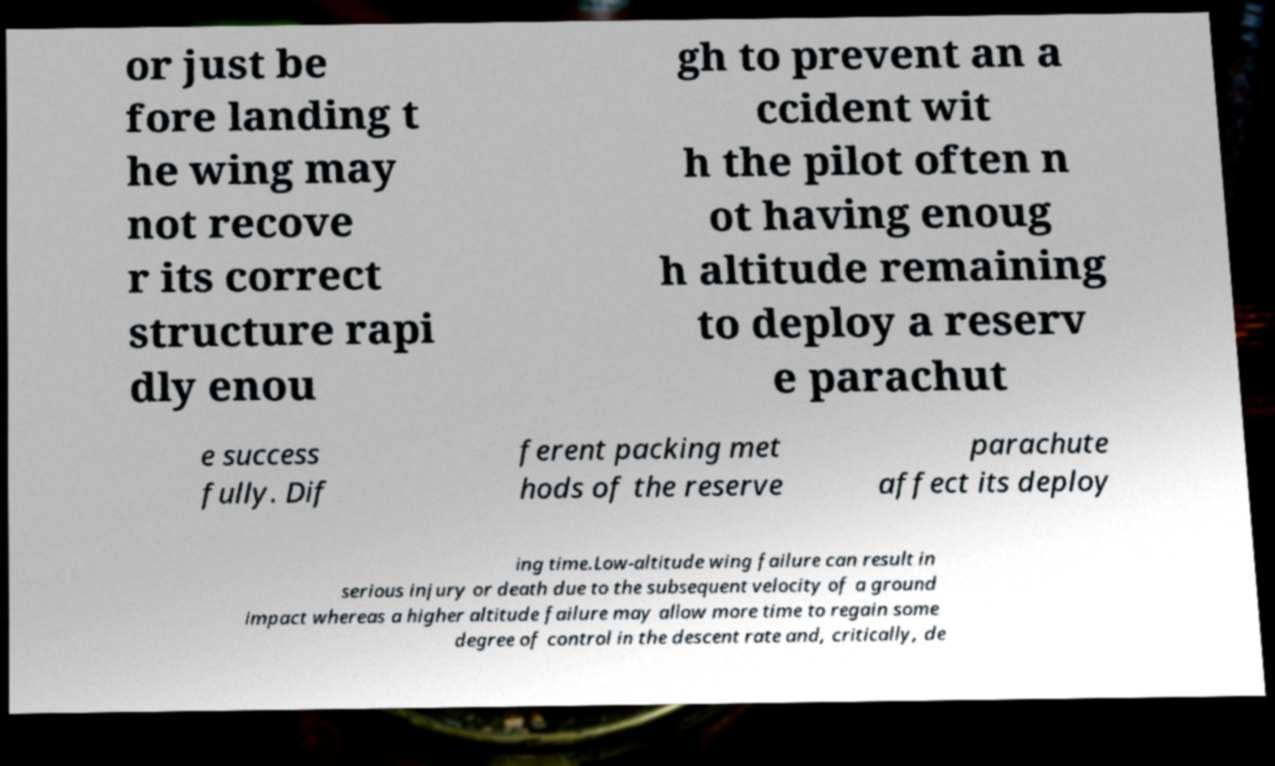What messages or text are displayed in this image? I need them in a readable, typed format. or just be fore landing t he wing may not recove r its correct structure rapi dly enou gh to prevent an a ccident wit h the pilot often n ot having enoug h altitude remaining to deploy a reserv e parachut e success fully. Dif ferent packing met hods of the reserve parachute affect its deploy ing time.Low-altitude wing failure can result in serious injury or death due to the subsequent velocity of a ground impact whereas a higher altitude failure may allow more time to regain some degree of control in the descent rate and, critically, de 